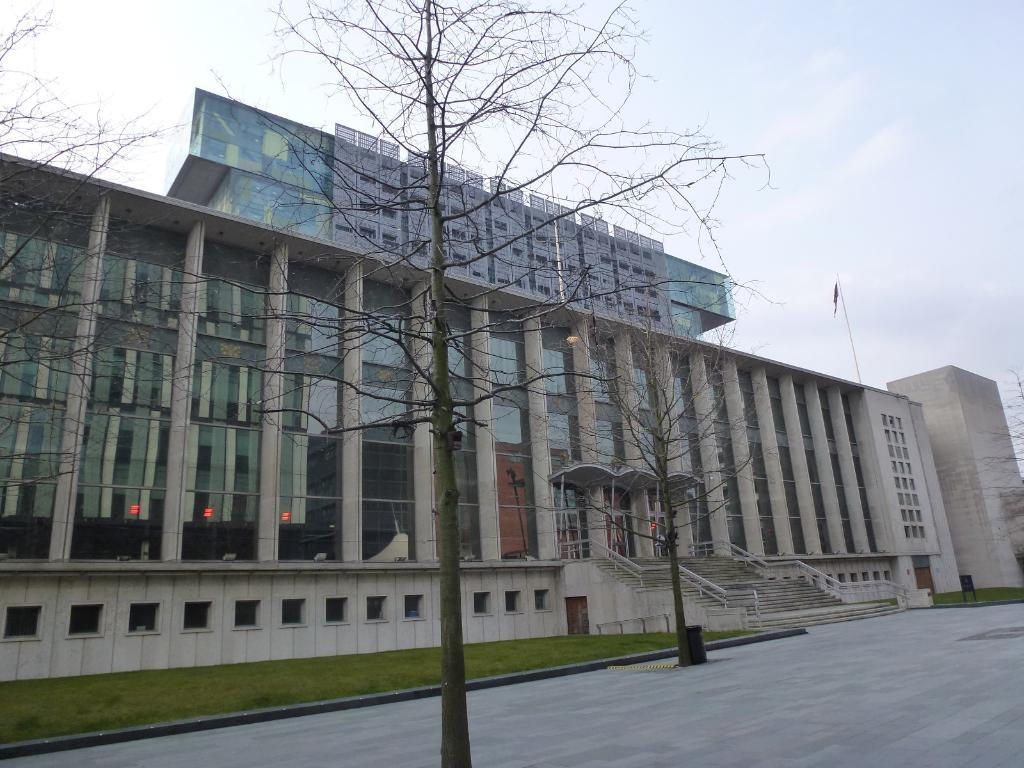What type of structure is visible in the image? There is a building in the image. What is located in front of the building? There are trees in front of the building. What can be seen in the background of the image? The sky is visible in the background of the image. What type of legal advice can be obtained from the band playing in the image? There is no band present in the image, and therefore no legal advice can be obtained from them. 